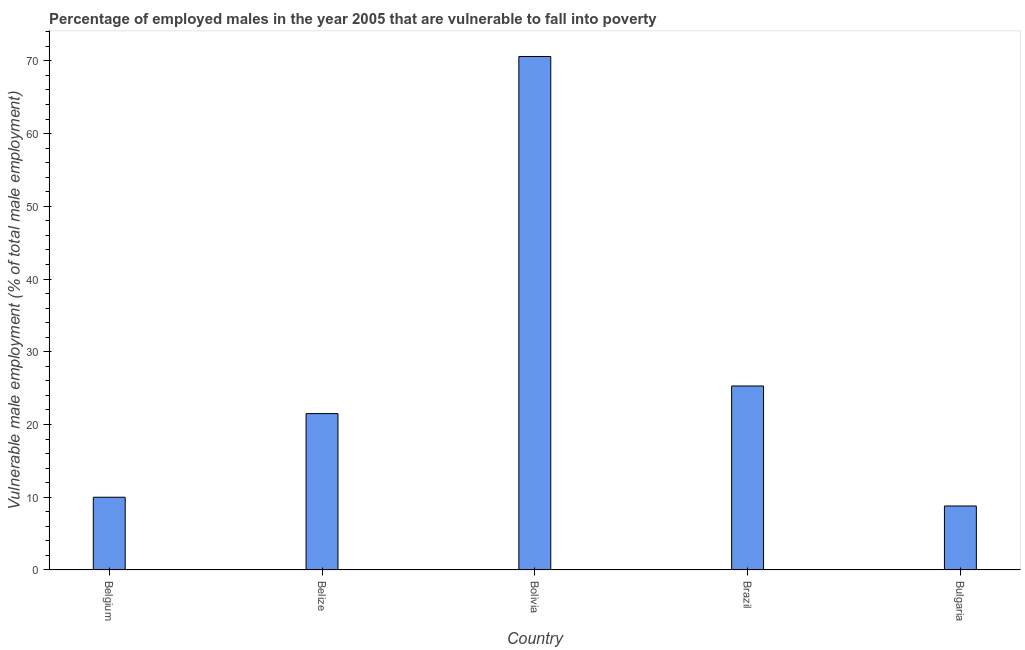What is the title of the graph?
Your response must be concise. Percentage of employed males in the year 2005 that are vulnerable to fall into poverty. What is the label or title of the X-axis?
Ensure brevity in your answer.  Country. What is the label or title of the Y-axis?
Make the answer very short. Vulnerable male employment (% of total male employment). What is the percentage of employed males who are vulnerable to fall into poverty in Brazil?
Keep it short and to the point. 25.3. Across all countries, what is the maximum percentage of employed males who are vulnerable to fall into poverty?
Keep it short and to the point. 70.6. Across all countries, what is the minimum percentage of employed males who are vulnerable to fall into poverty?
Offer a terse response. 8.8. In which country was the percentage of employed males who are vulnerable to fall into poverty minimum?
Ensure brevity in your answer.  Bulgaria. What is the sum of the percentage of employed males who are vulnerable to fall into poverty?
Provide a succinct answer. 136.2. What is the difference between the percentage of employed males who are vulnerable to fall into poverty in Belize and Brazil?
Offer a very short reply. -3.8. What is the average percentage of employed males who are vulnerable to fall into poverty per country?
Provide a short and direct response. 27.24. In how many countries, is the percentage of employed males who are vulnerable to fall into poverty greater than 16 %?
Ensure brevity in your answer.  3. What is the ratio of the percentage of employed males who are vulnerable to fall into poverty in Belgium to that in Bolivia?
Make the answer very short. 0.14. What is the difference between the highest and the second highest percentage of employed males who are vulnerable to fall into poverty?
Make the answer very short. 45.3. Is the sum of the percentage of employed males who are vulnerable to fall into poverty in Belgium and Bolivia greater than the maximum percentage of employed males who are vulnerable to fall into poverty across all countries?
Your response must be concise. Yes. What is the difference between the highest and the lowest percentage of employed males who are vulnerable to fall into poverty?
Ensure brevity in your answer.  61.8. Are all the bars in the graph horizontal?
Your answer should be very brief. No. What is the difference between two consecutive major ticks on the Y-axis?
Make the answer very short. 10. What is the Vulnerable male employment (% of total male employment) of Belize?
Your answer should be very brief. 21.5. What is the Vulnerable male employment (% of total male employment) of Bolivia?
Ensure brevity in your answer.  70.6. What is the Vulnerable male employment (% of total male employment) in Brazil?
Your answer should be very brief. 25.3. What is the Vulnerable male employment (% of total male employment) of Bulgaria?
Your response must be concise. 8.8. What is the difference between the Vulnerable male employment (% of total male employment) in Belgium and Belize?
Your answer should be very brief. -11.5. What is the difference between the Vulnerable male employment (% of total male employment) in Belgium and Bolivia?
Offer a very short reply. -60.6. What is the difference between the Vulnerable male employment (% of total male employment) in Belgium and Brazil?
Provide a succinct answer. -15.3. What is the difference between the Vulnerable male employment (% of total male employment) in Belize and Bolivia?
Keep it short and to the point. -49.1. What is the difference between the Vulnerable male employment (% of total male employment) in Belize and Brazil?
Ensure brevity in your answer.  -3.8. What is the difference between the Vulnerable male employment (% of total male employment) in Bolivia and Brazil?
Your answer should be compact. 45.3. What is the difference between the Vulnerable male employment (% of total male employment) in Bolivia and Bulgaria?
Offer a terse response. 61.8. What is the ratio of the Vulnerable male employment (% of total male employment) in Belgium to that in Belize?
Give a very brief answer. 0.47. What is the ratio of the Vulnerable male employment (% of total male employment) in Belgium to that in Bolivia?
Your response must be concise. 0.14. What is the ratio of the Vulnerable male employment (% of total male employment) in Belgium to that in Brazil?
Provide a short and direct response. 0.4. What is the ratio of the Vulnerable male employment (% of total male employment) in Belgium to that in Bulgaria?
Your answer should be very brief. 1.14. What is the ratio of the Vulnerable male employment (% of total male employment) in Belize to that in Bolivia?
Offer a terse response. 0.3. What is the ratio of the Vulnerable male employment (% of total male employment) in Belize to that in Bulgaria?
Offer a terse response. 2.44. What is the ratio of the Vulnerable male employment (% of total male employment) in Bolivia to that in Brazil?
Ensure brevity in your answer.  2.79. What is the ratio of the Vulnerable male employment (% of total male employment) in Bolivia to that in Bulgaria?
Your answer should be compact. 8.02. What is the ratio of the Vulnerable male employment (% of total male employment) in Brazil to that in Bulgaria?
Offer a terse response. 2.88. 